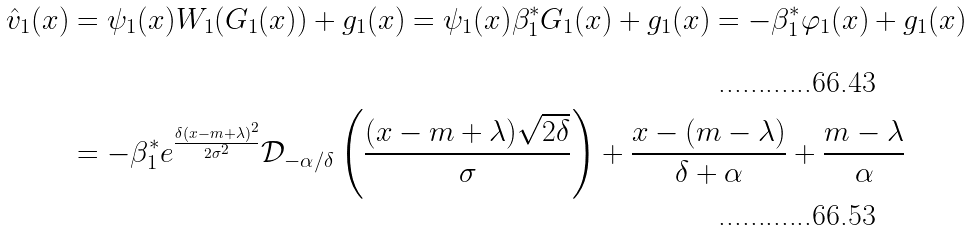<formula> <loc_0><loc_0><loc_500><loc_500>\hat { v } _ { 1 } ( x ) & = \psi _ { 1 } ( x ) W _ { 1 } ( G _ { 1 } ( x ) ) + g _ { 1 } ( x ) = \psi _ { 1 } ( x ) \beta _ { 1 } ^ { * } G _ { 1 } ( x ) + g _ { 1 } ( x ) = - \beta _ { 1 } ^ { * } \varphi _ { 1 } ( x ) + g _ { 1 } ( x ) \\ & = - \beta _ { 1 } ^ { * } e ^ { \frac { \delta ( x - m + \lambda ) ^ { 2 } } { 2 \sigma ^ { 2 } } } \mathcal { D } _ { - \alpha / \delta } \left ( \frac { ( x - m + \lambda ) \sqrt { 2 \delta } } { \sigma } \right ) + \frac { x - ( m - \lambda ) } { \delta + \alpha } + \frac { m - \lambda } { \alpha }</formula> 